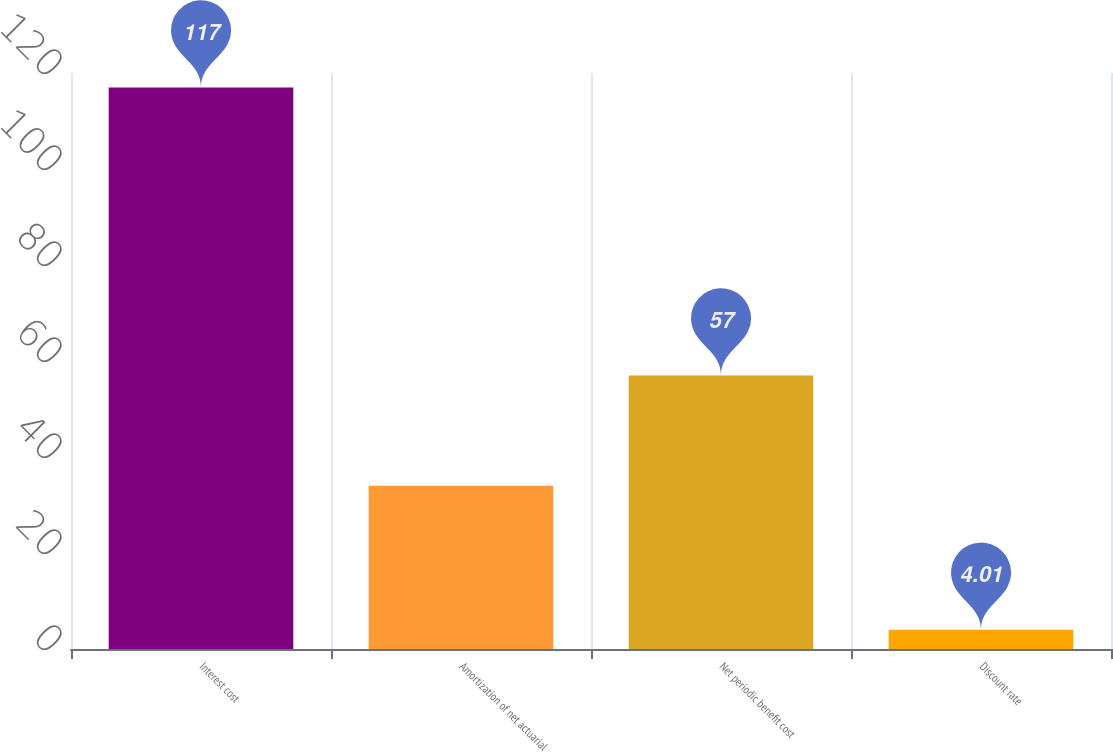<chart> <loc_0><loc_0><loc_500><loc_500><bar_chart><fcel>Interest cost<fcel>Amortization of net actuarial<fcel>Net periodic benefit cost<fcel>Discount rate<nl><fcel>117<fcel>34<fcel>57<fcel>4.01<nl></chart> 